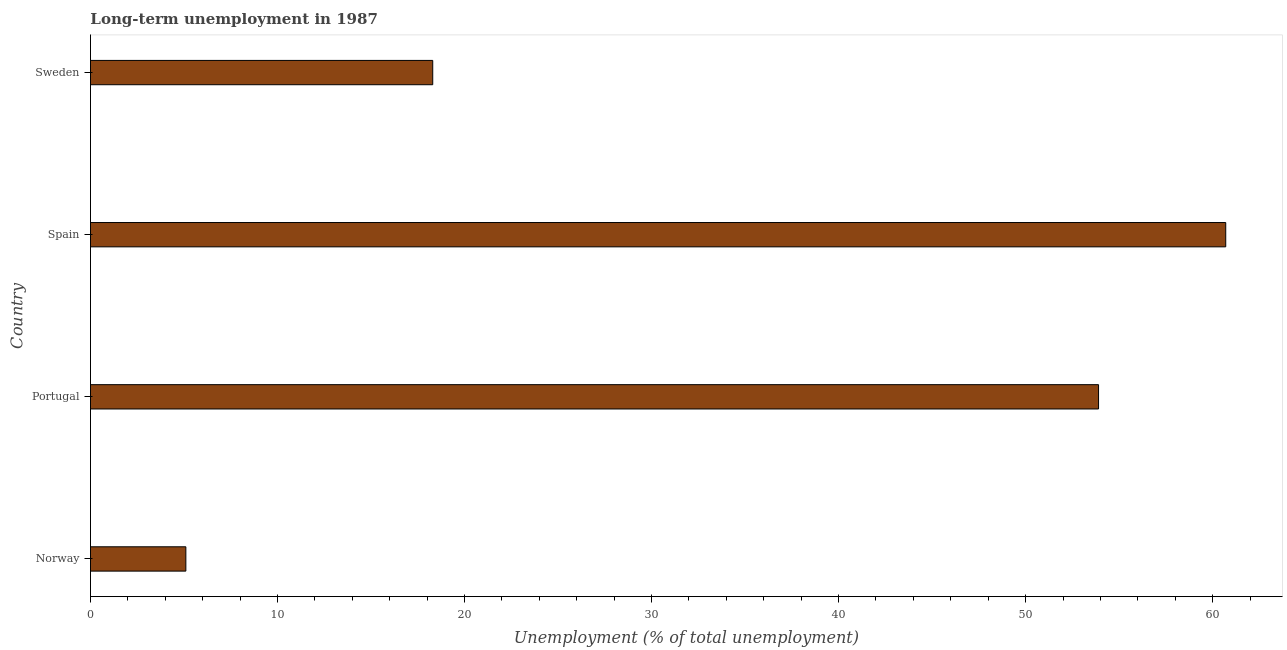Does the graph contain grids?
Your answer should be very brief. No. What is the title of the graph?
Provide a short and direct response. Long-term unemployment in 1987. What is the label or title of the X-axis?
Make the answer very short. Unemployment (% of total unemployment). What is the long-term unemployment in Sweden?
Make the answer very short. 18.3. Across all countries, what is the maximum long-term unemployment?
Your answer should be very brief. 60.7. Across all countries, what is the minimum long-term unemployment?
Your response must be concise. 5.1. In which country was the long-term unemployment maximum?
Offer a very short reply. Spain. What is the sum of the long-term unemployment?
Ensure brevity in your answer.  138. What is the difference between the long-term unemployment in Norway and Sweden?
Make the answer very short. -13.2. What is the average long-term unemployment per country?
Provide a succinct answer. 34.5. What is the median long-term unemployment?
Offer a terse response. 36.1. In how many countries, is the long-term unemployment greater than 44 %?
Your response must be concise. 2. What is the ratio of the long-term unemployment in Norway to that in Portugal?
Give a very brief answer. 0.1. Is the difference between the long-term unemployment in Norway and Sweden greater than the difference between any two countries?
Provide a succinct answer. No. What is the difference between the highest and the lowest long-term unemployment?
Make the answer very short. 55.6. In how many countries, is the long-term unemployment greater than the average long-term unemployment taken over all countries?
Your response must be concise. 2. How many countries are there in the graph?
Make the answer very short. 4. What is the Unemployment (% of total unemployment) of Norway?
Offer a terse response. 5.1. What is the Unemployment (% of total unemployment) in Portugal?
Give a very brief answer. 53.9. What is the Unemployment (% of total unemployment) in Spain?
Your answer should be very brief. 60.7. What is the Unemployment (% of total unemployment) in Sweden?
Your response must be concise. 18.3. What is the difference between the Unemployment (% of total unemployment) in Norway and Portugal?
Make the answer very short. -48.8. What is the difference between the Unemployment (% of total unemployment) in Norway and Spain?
Your answer should be very brief. -55.6. What is the difference between the Unemployment (% of total unemployment) in Portugal and Spain?
Offer a terse response. -6.8. What is the difference between the Unemployment (% of total unemployment) in Portugal and Sweden?
Your answer should be compact. 35.6. What is the difference between the Unemployment (% of total unemployment) in Spain and Sweden?
Your answer should be very brief. 42.4. What is the ratio of the Unemployment (% of total unemployment) in Norway to that in Portugal?
Provide a succinct answer. 0.1. What is the ratio of the Unemployment (% of total unemployment) in Norway to that in Spain?
Your answer should be very brief. 0.08. What is the ratio of the Unemployment (% of total unemployment) in Norway to that in Sweden?
Ensure brevity in your answer.  0.28. What is the ratio of the Unemployment (% of total unemployment) in Portugal to that in Spain?
Keep it short and to the point. 0.89. What is the ratio of the Unemployment (% of total unemployment) in Portugal to that in Sweden?
Your answer should be very brief. 2.94. What is the ratio of the Unemployment (% of total unemployment) in Spain to that in Sweden?
Your response must be concise. 3.32. 